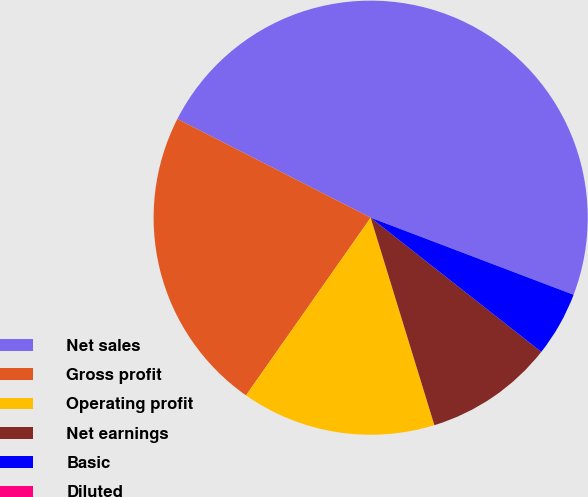<chart> <loc_0><loc_0><loc_500><loc_500><pie_chart><fcel>Net sales<fcel>Gross profit<fcel>Operating profit<fcel>Net earnings<fcel>Basic<fcel>Diluted<nl><fcel>48.26%<fcel>22.78%<fcel>14.48%<fcel>9.65%<fcel>4.83%<fcel>0.0%<nl></chart> 